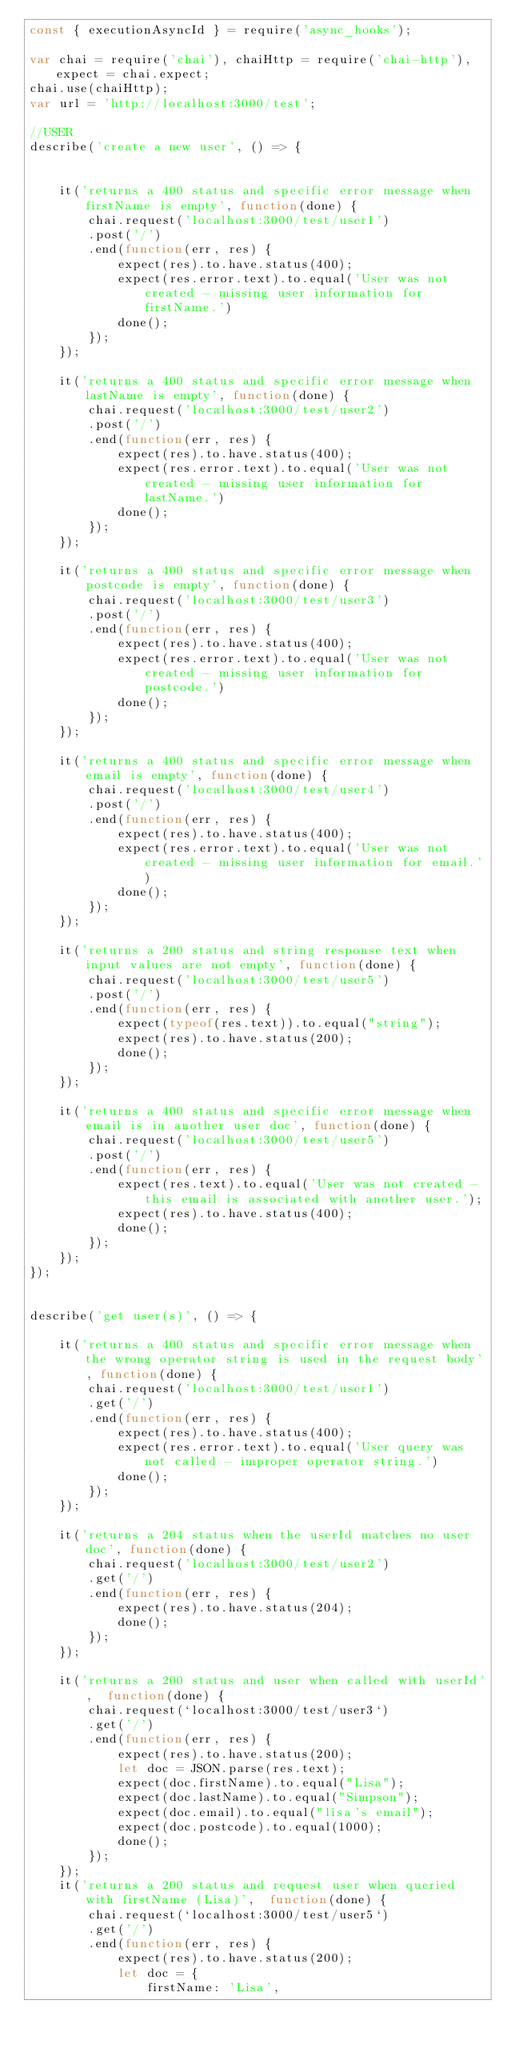<code> <loc_0><loc_0><loc_500><loc_500><_JavaScript_>const { executionAsyncId } = require('async_hooks');

var chai = require('chai'), chaiHttp = require('chai-http'), expect = chai.expect;
chai.use(chaiHttp);
var url = 'http://localhost:3000/test';

//USER
describe('create a new user', () => {

    
    it('returns a 400 status and specific error message when firstName is empty', function(done) { 
        chai.request('localhost:3000/test/user1')
        .post('/')
        .end(function(err, res) {
            expect(res).to.have.status(400);
            expect(res.error.text).to.equal('User was not created - missing user information for firstName.')
            done();                               
        });
    });

    it('returns a 400 status and specific error message when lastName is empty', function(done) { 
        chai.request('localhost:3000/test/user2')
        .post('/')
        .end(function(err, res) {
            expect(res).to.have.status(400);
            expect(res.error.text).to.equal('User was not created - missing user information for lastName.')
            done();                               
        });
    });
    
    it('returns a 400 status and specific error message when postcode is empty', function(done) { 
        chai.request('localhost:3000/test/user3')
        .post('/')
        .end(function(err, res) {
            expect(res).to.have.status(400);
            expect(res.error.text).to.equal('User was not created - missing user information for postcode.')
            done();                               
        });
    });
    
    it('returns a 400 status and specific error message when email is empty', function(done) { 
        chai.request('localhost:3000/test/user4')
        .post('/')
        .end(function(err, res) {
            expect(res).to.have.status(400);
            expect(res.error.text).to.equal('User was not created - missing user information for email.')
            done();                               
        });
    }); 
    
    it('returns a 200 status and string response text when input values are not empty', function(done) { 
        chai.request('localhost:3000/test/user5')
        .post('/')
        .end(function(err, res) {
            expect(typeof(res.text)).to.equal("string");
            expect(res).to.have.status(200);
            done();                               
        });
    });
    
    it('returns a 400 status and specific error message when email is in another user doc', function(done) { 
        chai.request('localhost:3000/test/user5')
        .post('/')
        .end(function(err, res) {
            expect(res.text).to.equal('User was not created - this email is associated with another user.');
            expect(res).to.have.status(400);
            done();                               
        });
    });
});


describe('get user(s)', () => {

    it('returns a 400 status and specific error message when the wrong operator string is used in the request body', function(done) { 
        chai.request('localhost:3000/test/user1')
        .get('/')
        .end(function(err, res) {
            expect(res).to.have.status(400);
            expect(res.error.text).to.equal('User query was not called - improper operator string.')
            done();                               
        });
    });

    it('returns a 204 status when the userId matches no user doc', function(done) { 
        chai.request('localhost:3000/test/user2')
        .get('/')
        .end(function(err, res) {
            expect(res).to.have.status(204);
            done();                               
        });
    });

    it('returns a 200 status and user when called with userId',  function(done) { 
        chai.request(`localhost:3000/test/user3`)
        .get('/')
        .end(function(err, res) {
            expect(res).to.have.status(200);
            let doc = JSON.parse(res.text);
            expect(doc.firstName).to.equal("Lisa");
            expect(doc.lastName).to.equal("Simpson");
            expect(doc.email).to.equal("lisa's email");
            expect(doc.postcode).to.equal(1000);
            done();                               
        });
    });
    it('returns a 200 status and request user when queried with firstName (Lisa)',  function(done) { 
        chai.request(`localhost:3000/test/user5`)
        .get('/')
        .end(function(err, res) {
            expect(res).to.have.status(200);
            let doc = {
                firstName: 'Lisa',</code> 